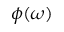<formula> <loc_0><loc_0><loc_500><loc_500>\phi ( \omega )</formula> 